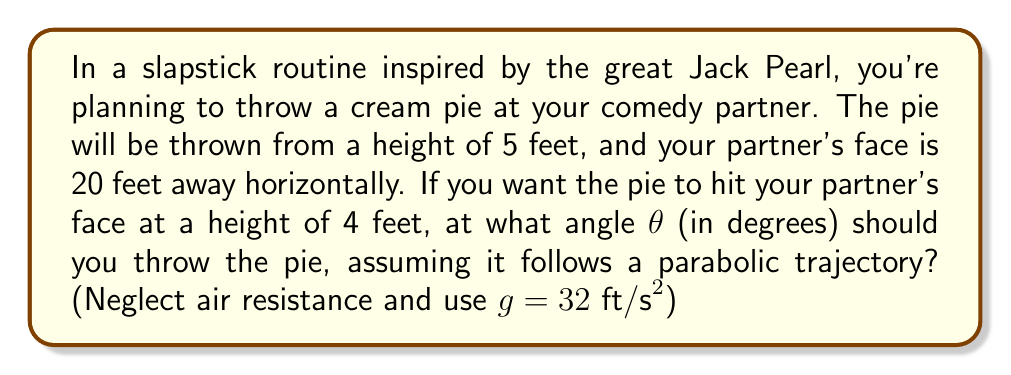Give your solution to this math problem. Let's approach this step-by-step:

1) The trajectory of the pie follows a parabolic path described by the equation:
   $$y = -\frac{gx^2}{2v_0^2\cos^2\theta} + x\tan\theta + h_0$$
   where $y$ is the vertical position, $x$ is the horizontal position, $v_0$ is the initial velocity, $\theta$ is the launch angle, and $h_0$ is the initial height.

2) We know:
   - Initial height $h_0 = 5$ ft
   - Horizontal distance $x = 20$ ft
   - Final height $y = 4$ ft
   - Acceleration due to gravity $g = 32$ ft/s²

3) Substituting these values into the equation:
   $$4 = -\frac{32(20^2)}{2v_0^2\cos^2\theta} + 20\tan\theta + 5$$

4) Simplify:
   $$-1 = -\frac{6400}{v_0^2\cos^2\theta} + 20\tan\theta$$

5) We can eliminate $v_0$ by using the range equation:
   $$x = \frac{v_0^2\sin(2\theta)}{g}$$

6) Substituting and solving for $v_0^2$:
   $$20 = \frac{v_0^2\sin(2\theta)}{32}$$
   $$v_0^2 = \frac{640}{\sin(2\theta)}$$

7) Substitute this back into the equation from step 4:
   $$-1 = -\frac{6400\sin(2\theta)}{640} + 20\tan\theta$$
   $$-1 = -10\sin(2\theta) + 20\tan\theta$$

8) Use the identity $\sin(2\theta) = 2\sin\theta\cos\theta$:
   $$-1 = -20\sin\theta\cos\theta + 20\tan\theta$$

9) Simplify using $\tan\theta = \frac{\sin\theta}{\cos\theta}$:
   $$-1 = -20\sin\theta\cos\theta + 20\frac{\sin\theta}{\cos\theta}$$

10) Multiply both sides by $\cos\theta$:
    $$-\cos\theta = -20\sin\theta\cos^2\theta + 20\sin\theta$$

11) Rearrange:
    $$20\sin\theta\cos^2\theta - 20\sin\theta + \cos\theta = 0$$

12) This equation can be solved numerically. Using a calculator or computational method, we find:
    $$\theta \approx 15.07°$$
Answer: $15.07°$ 